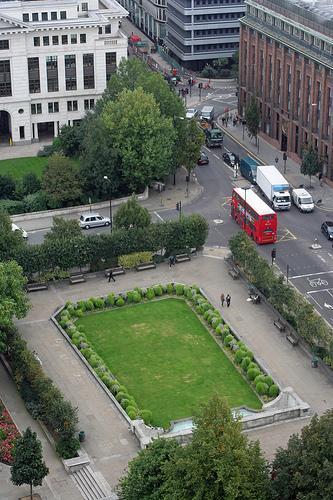How many red double-decker buses are there?
Give a very brief answer. 1. 